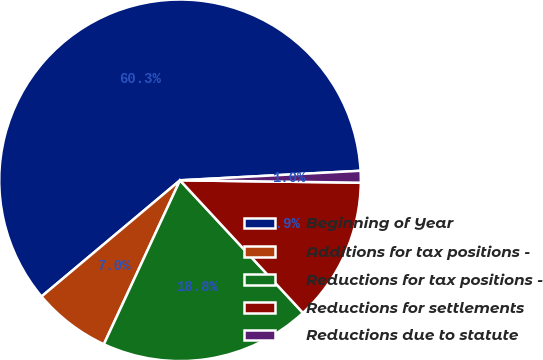<chart> <loc_0><loc_0><loc_500><loc_500><pie_chart><fcel>Beginning of Year<fcel>Additions for tax positions -<fcel>Reductions for tax positions -<fcel>Reductions for settlements<fcel>Reductions due to statute<nl><fcel>60.27%<fcel>6.97%<fcel>18.82%<fcel>12.89%<fcel>1.05%<nl></chart> 